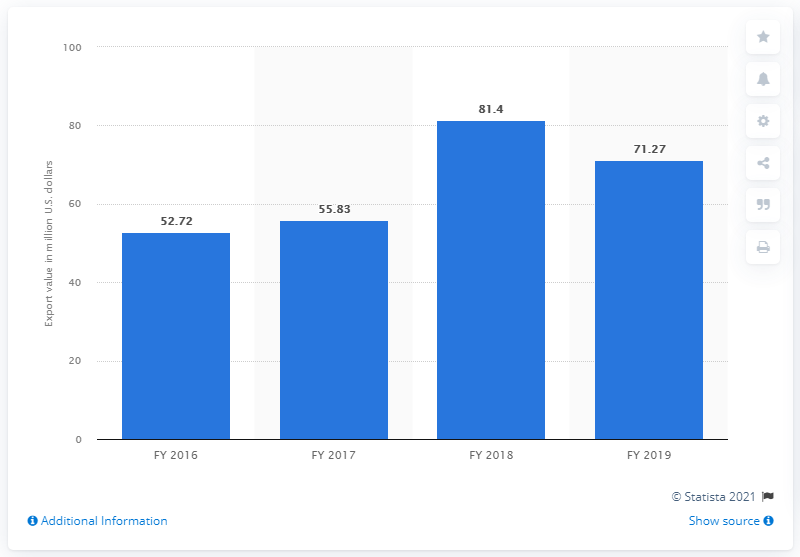Identify some key points in this picture. In the fiscal year 2019, the value of mica exports from India was 71.27 million dollars. 